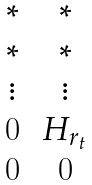<formula> <loc_0><loc_0><loc_500><loc_500>\begin{matrix} * & * \\ * & * \\ \vdots & \vdots \\ 0 & \, H _ { r _ { t } } \, \\ 0 & 0 \end{matrix}</formula> 